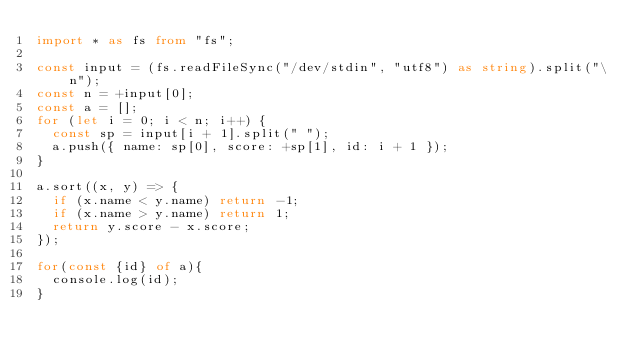<code> <loc_0><loc_0><loc_500><loc_500><_TypeScript_>import * as fs from "fs";

const input = (fs.readFileSync("/dev/stdin", "utf8") as string).split("\n");
const n = +input[0];
const a = [];
for (let i = 0; i < n; i++) {
  const sp = input[i + 1].split(" ");
  a.push({ name: sp[0], score: +sp[1], id: i + 1 });
}

a.sort((x, y) => {
  if (x.name < y.name) return -1;
  if (x.name > y.name) return 1;
  return y.score - x.score;
});

for(const {id} of a){
  console.log(id);
}
</code> 